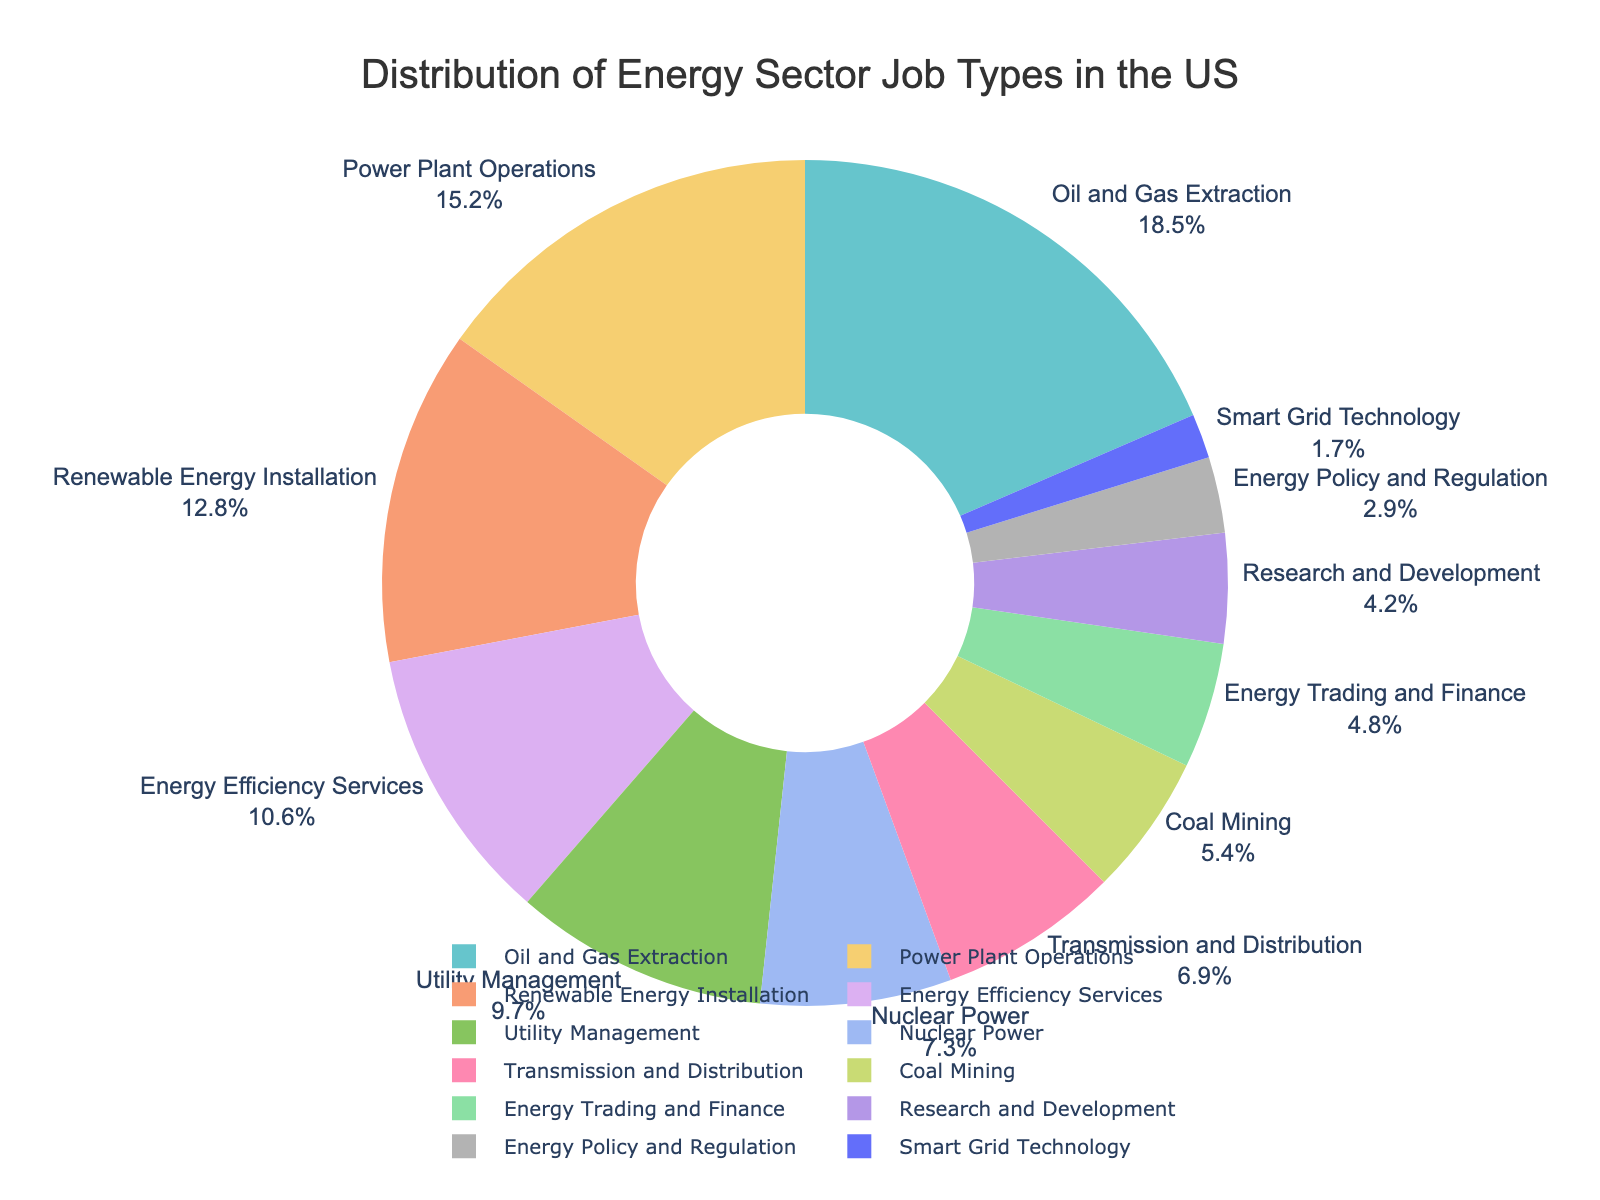What is the percentage of jobs in the Oil and Gas Extraction sector? You can directly read the percentage allocated to the Oil and Gas Extraction sector from the pie chart. Look for the label "Oil and Gas Extraction" and note its percentage.
Answer: 18.5% Which job type has the lowest percentage of jobs, and what is that percentage? To find the job type with the lowest percentage, look for the smallest segment in the chart and read its label and value. The lowest job type is "Smart Grid Technology," with the lowest percentage.
Answer: Smart Grid Technology, 1.7% How much more is the percentage of jobs in Power Plant Operations than in Coal Mining? Read the percentages for Power Plant Operations and Coal Mining from the chart. Subtract the percentage of Coal Mining (5.4%) from Power Plant Operations (15.2%).
Answer: 9.8% What is the combined percentage of jobs in Renewable Energy Installation and Energy Efficiency Services? Locate the percentages for Renewable Energy Installation (12.8%) and Energy Efficiency Services (10.6%) from the chart. Add them together: 12.8% + 10.6%.
Answer: 23.4% Is there more percentage allocated to Energy Policy and Regulation or Energy Trading and Finance? Compare the segments for Energy Policy and Regulation and Energy Trading and Finance. Energy Trading and Finance has a higher percentage (4.8%) than Energy Policy and Regulation (2.9%).
Answer: Energy Trading and Finance What total percentage of jobs is present in Nuclear Power, Transmission and Distribution, and Coal Mining combined? Add the percentages for Nuclear Power (7.3%), Transmission and Distribution (6.9%), and Coal Mining (5.4%). 7.3% + 6.9% + 5.4%
Answer: 19.6% Which job type segment is located closest to the top of the chart, and what is its percentage? The top of the pie chart usually displays the first listed segment in a clockwise order. Verify the visual position and find that the "Oil and Gas Extraction" segment is located near the top. The percentage for this segment is 18.5%.
Answer: Oil and Gas Extraction, 18.5% 